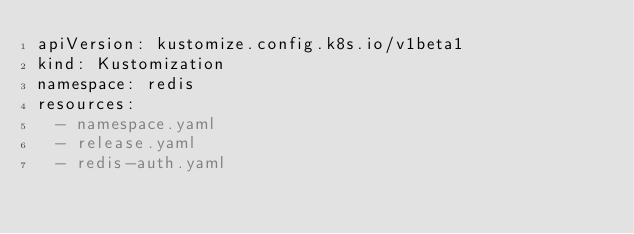Convert code to text. <code><loc_0><loc_0><loc_500><loc_500><_YAML_>apiVersion: kustomize.config.k8s.io/v1beta1
kind: Kustomization
namespace: redis
resources:
  - namespace.yaml
  - release.yaml
  - redis-auth.yaml
</code> 